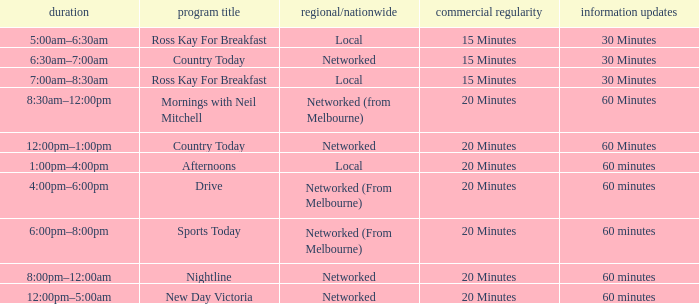Could you help me parse every detail presented in this table? {'header': ['duration', 'program title', 'regional/nationwide', 'commercial regularity', 'information updates'], 'rows': [['5:00am–6:30am', 'Ross Kay For Breakfast', 'Local', '15 Minutes', '30 Minutes'], ['6:30am–7:00am', 'Country Today', 'Networked', '15 Minutes', '30 Minutes'], ['7:00am–8:30am', 'Ross Kay For Breakfast', 'Local', '15 Minutes', '30 Minutes'], ['8:30am–12:00pm', 'Mornings with Neil Mitchell', 'Networked (from Melbourne)', '20 Minutes', '60 Minutes'], ['12:00pm–1:00pm', 'Country Today', 'Networked', '20 Minutes', '60 Minutes'], ['1:00pm–4:00pm', 'Afternoons', 'Local', '20 Minutes', '60 minutes'], ['4:00pm–6:00pm', 'Drive', 'Networked (From Melbourne)', '20 Minutes', '60 minutes'], ['6:00pm–8:00pm', 'Sports Today', 'Networked (From Melbourne)', '20 Minutes', '60 minutes'], ['8:00pm–12:00am', 'Nightline', 'Networked', '20 Minutes', '60 minutes'], ['12:00pm–5:00am', 'New Day Victoria', 'Networked', '20 Minutes', '60 minutes']]} What Ad Freq has a News Freq of 60 minutes, and a Local/Networked of local? 20 Minutes. 